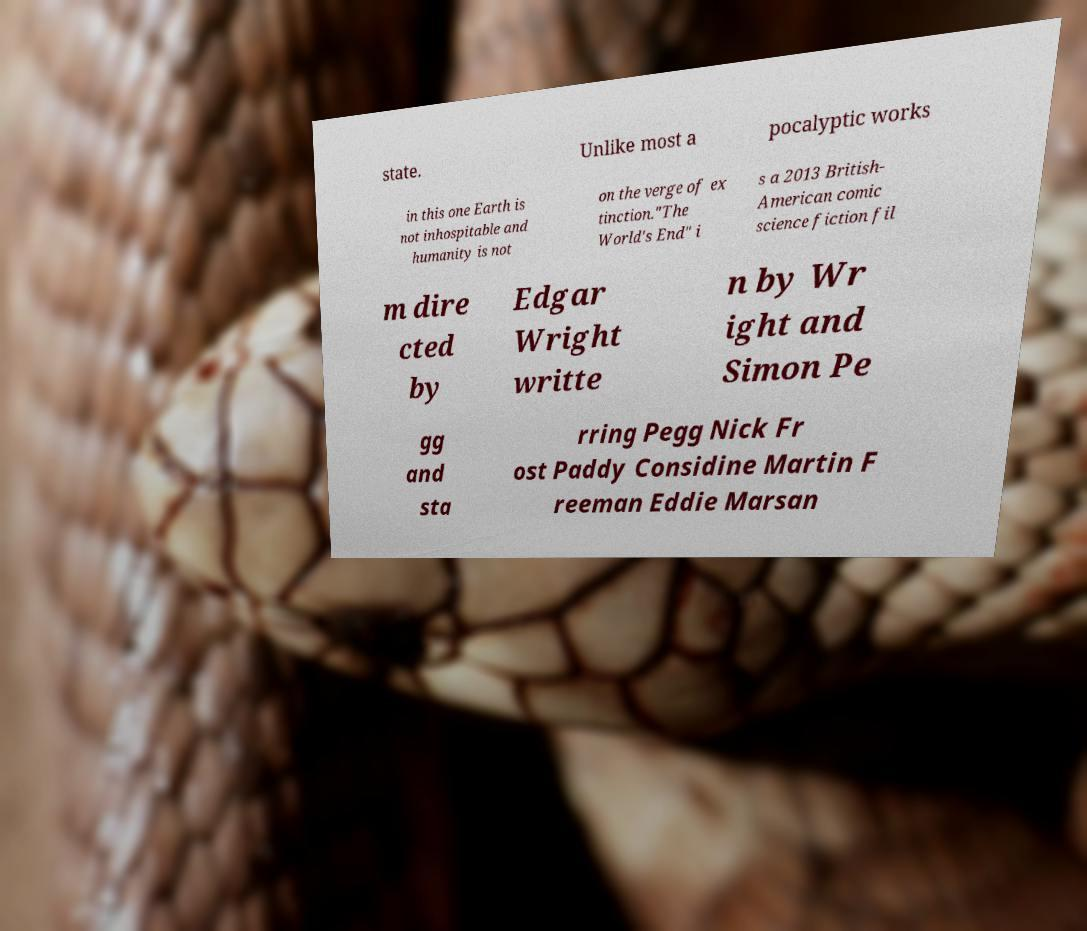Could you assist in decoding the text presented in this image and type it out clearly? state. Unlike most a pocalyptic works in this one Earth is not inhospitable and humanity is not on the verge of ex tinction."The World's End" i s a 2013 British- American comic science fiction fil m dire cted by Edgar Wright writte n by Wr ight and Simon Pe gg and sta rring Pegg Nick Fr ost Paddy Considine Martin F reeman Eddie Marsan 